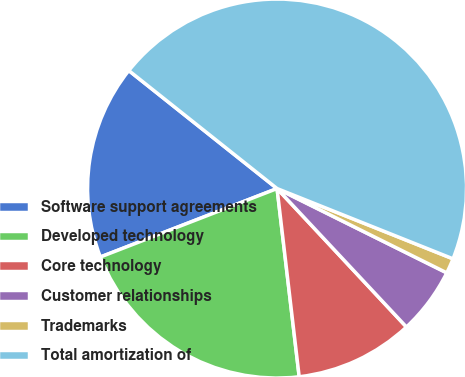Convert chart. <chart><loc_0><loc_0><loc_500><loc_500><pie_chart><fcel>Software support agreements<fcel>Developed technology<fcel>Core technology<fcel>Customer relationships<fcel>Trademarks<fcel>Total amortization of<nl><fcel>16.58%<fcel>20.98%<fcel>10.1%<fcel>5.7%<fcel>1.29%<fcel>45.35%<nl></chart> 